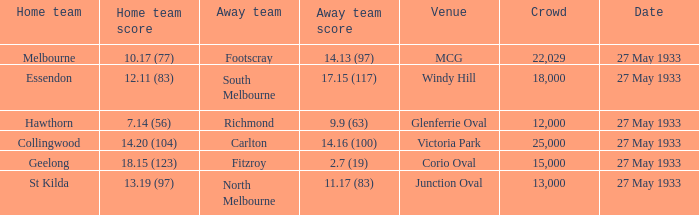In the match where the home team scored 14.20 (104), how many attendees were in the crowd? 25000.0. 